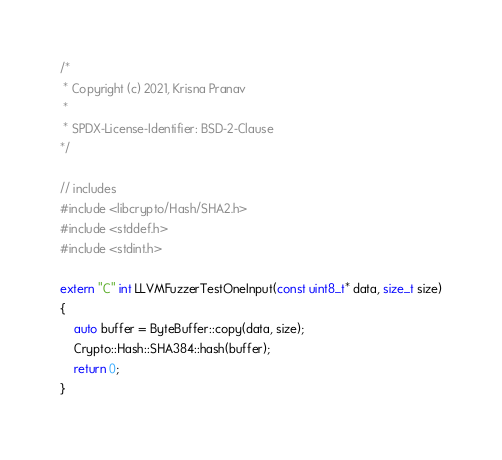Convert code to text. <code><loc_0><loc_0><loc_500><loc_500><_C++_>/*
 * Copyright (c) 2021, Krisna Pranav
 *
 * SPDX-License-Identifier: BSD-2-Clause
*/

// includes
#include <libcrypto/Hash/SHA2.h>
#include <stddef.h>
#include <stdint.h>

extern "C" int LLVMFuzzerTestOneInput(const uint8_t* data, size_t size)
{
    auto buffer = ByteBuffer::copy(data, size);
    Crypto::Hash::SHA384::hash(buffer);
    return 0;
}</code> 